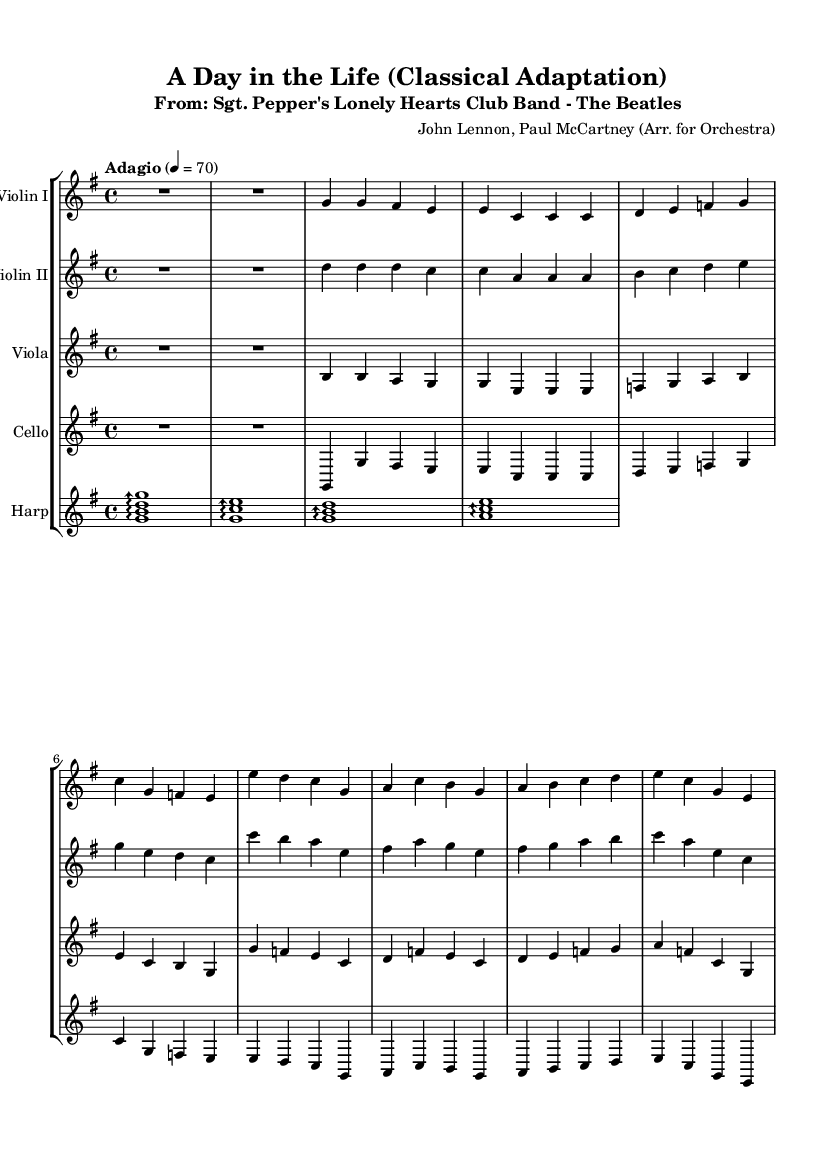What is the key signature of this music? The key signature is G major, which contains one sharp (F#). You can determine this from the key signature at the beginning of the score where the sharp is placed on the F line.
Answer: G major What is the time signature of this music? The time signature is 4/4, indicated at the beginning of the score between the clef and the key signature. This means there are four beats in each measure and the quarter note gets one beat.
Answer: 4/4 What is the tempo marking given in the music? The tempo marking at the beginning states "Adagio" with a metronome marking of 70. "Adagio" indicates a slow tempo, and the number provides a specific speed in beats per minute.
Answer: Adagio, 70 How many measures are there in the Violin I part? Counting the measures in the Violin I part from the beginning to the end, we see there are eight measures in total indicated by the bar lines.
Answer: Eight Which instrument has the lowest pitch in this score? The instrument with the lowest pitch is the cello, as it is written in the bass clef, which typically contains lower notes than the violin or viola parts written in treble and alto clefs respectively.
Answer: Cello What kind of musical texture is presented when Violin I plays with Viola? The score shows a homophonic texture when Violin I and Viola play together; Violin I provides a melody while Viola mainly supports with harmony. This can be inferred from how the two parts interact, creating a richer sound together rather than competing melodies.
Answer: Homophonic 